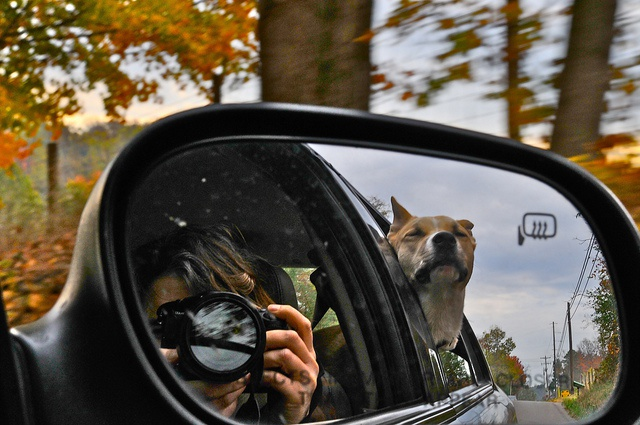Describe the objects in this image and their specific colors. I can see car in darkgreen, black, gray, and darkgray tones, people in darkgreen, black, maroon, and gray tones, and dog in darkgreen, black, gray, and maroon tones in this image. 